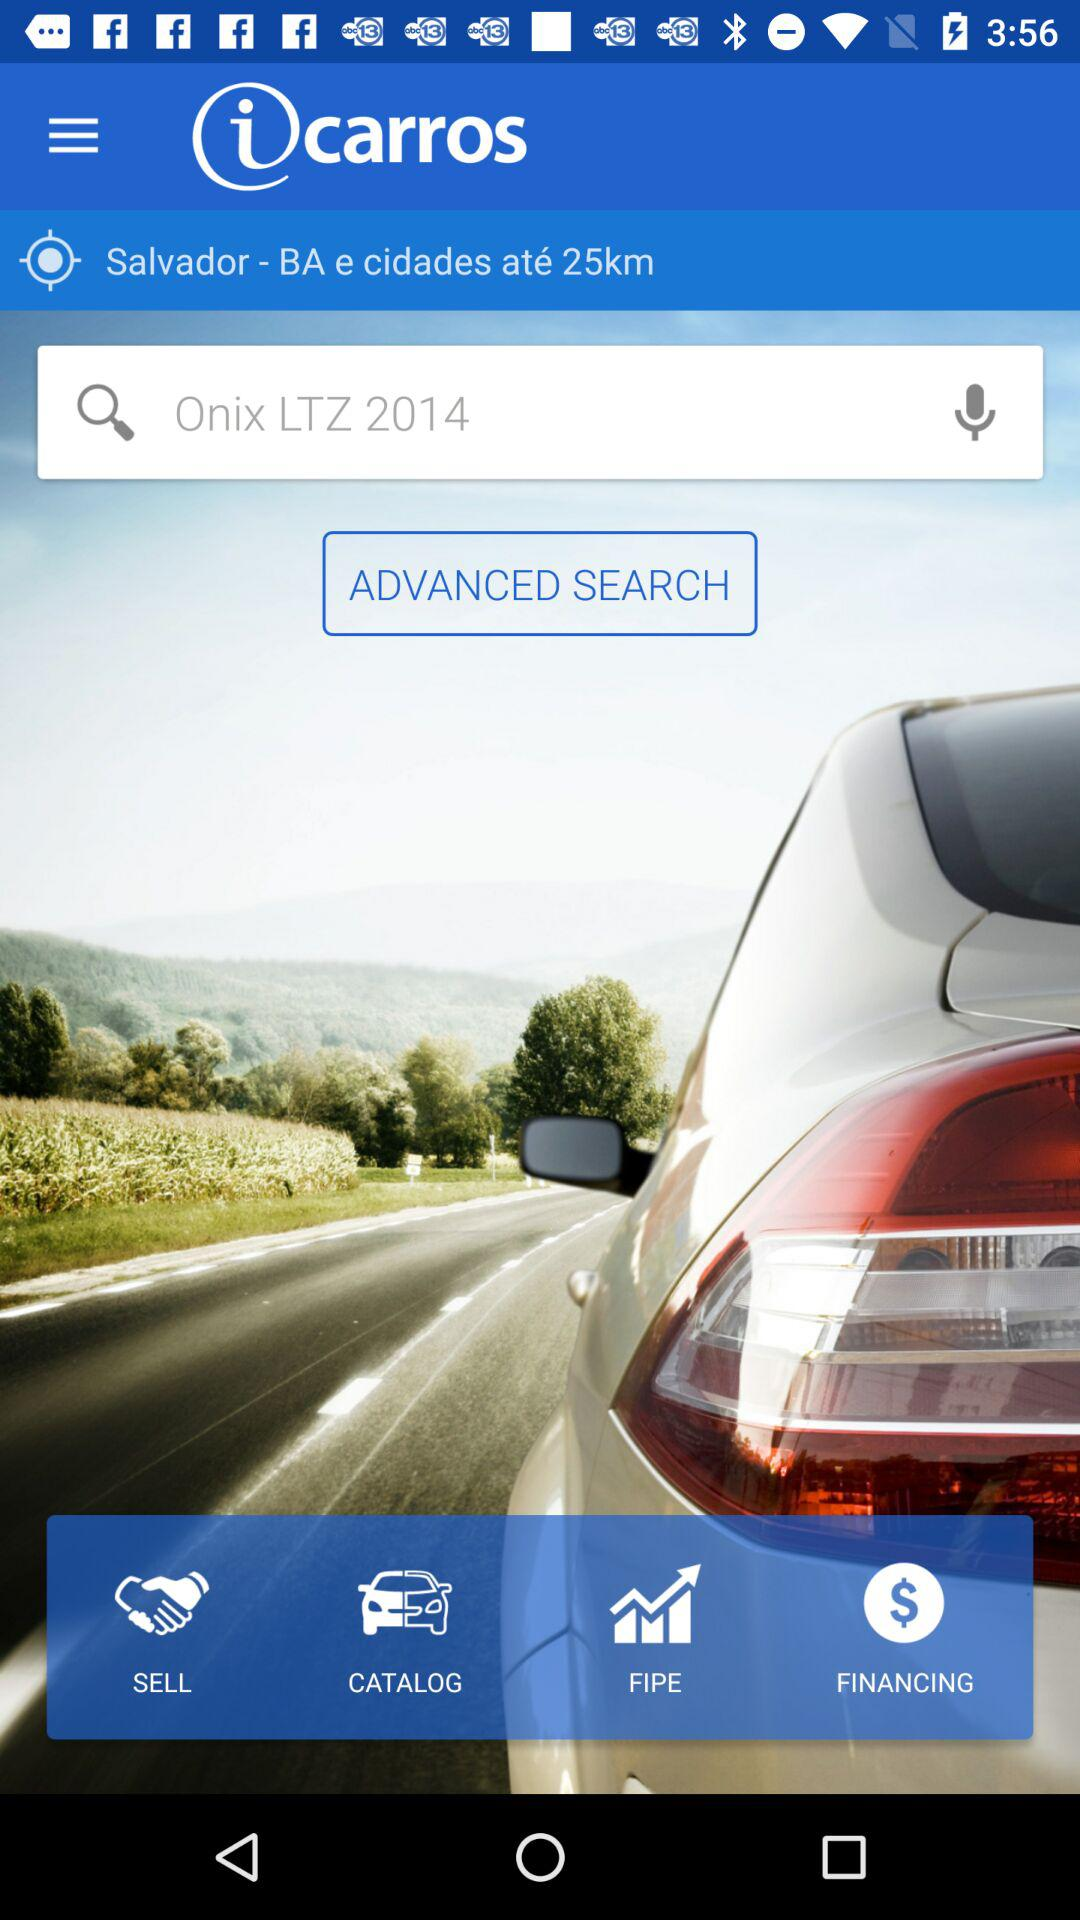What model of car has been searched for? The model of car that has been searched for is the "Onix LTZ 2014". 